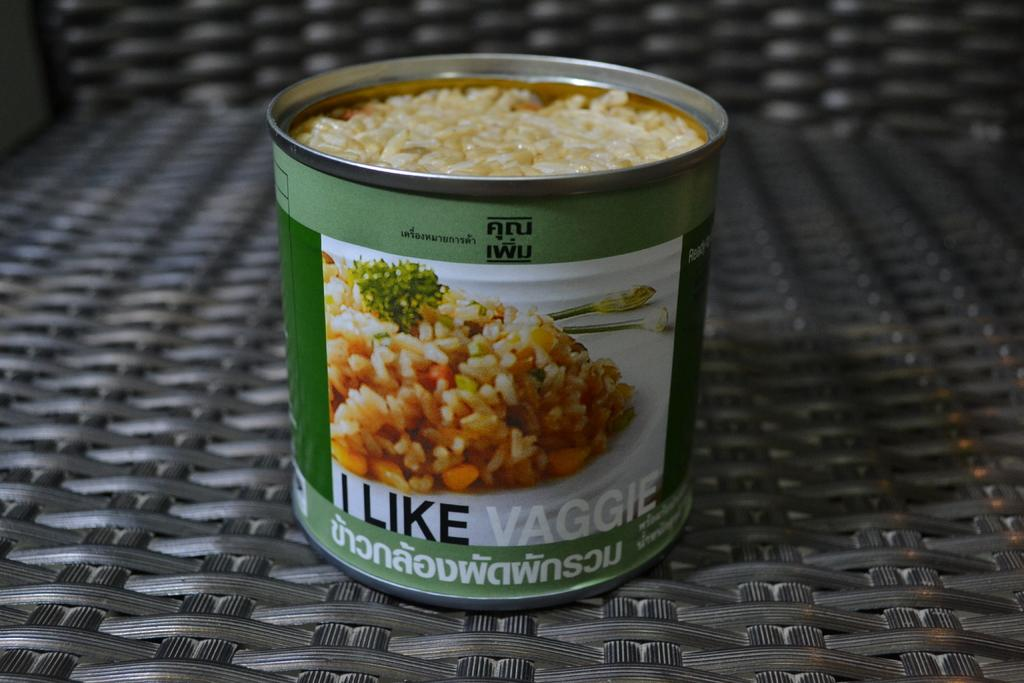What object is present in the image? There is a box in the image. What is inside the box? The box contains food. Where is the box located? The box is on a chair. Is the stranger using the box as bait in the image? There is no stranger or bait present in the image; it only features a box containing food on a chair. 